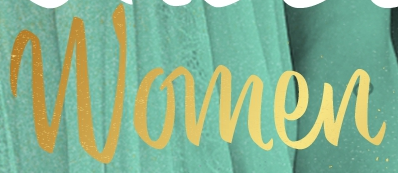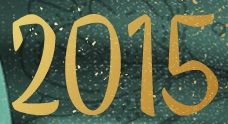What words are shown in these images in order, separated by a semicolon? Women; 2015 